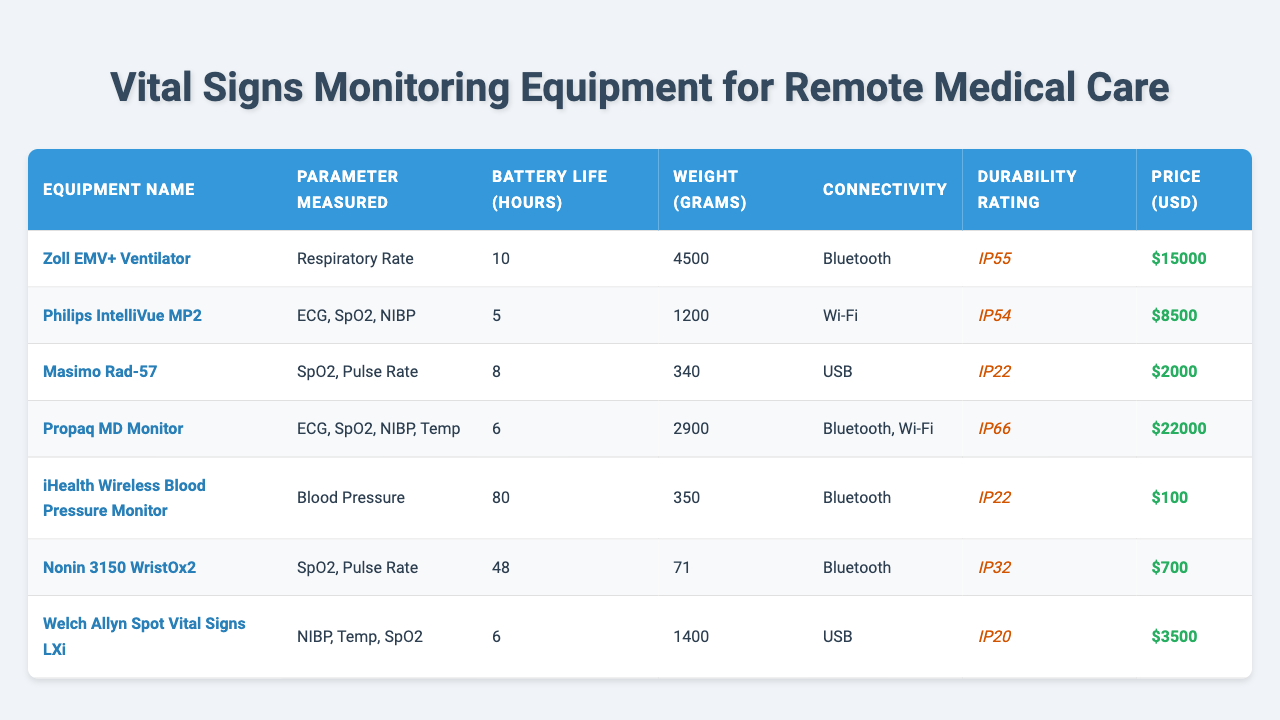What is the weight of the Zoll EMV+ Ventilator? The table lists the weight of the Zoll EMV+ Ventilator as 4500 grams.
Answer: 4500 grams How many parameters can the Propaq MD Monitor measure? The Propaq MD Monitor can measure ECG, SpO2, NIBP, and Temp, totaling 4 parameters.
Answer: 4 parameters Which equipment has the longest battery life? The iHealth Wireless Blood Pressure Monitor has a battery life of 80 hours, which is the longest among the listed equipment.
Answer: 80 hours Is the Masimo Rad-57 device the lightest among the options? Comparing all weights, the Masimo Rad-57 weighs 340 grams, which is lighter than most other devices, making it the lightest.
Answer: Yes What is the total price of the Zoll EMV+ Ventilator and Philips IntelliVue MP2? The prices are $15000 and $8500, respectively. Adding them gives $15000 + $8500 = $23500.
Answer: $23500 How many devices have a durability rating of IP66? The table shows that only the Propaq MD Monitor has a durability rating of IP66.
Answer: 1 device Which device measures Blood Pressure, and what is its price? The iHealth Wireless Blood Pressure Monitor measures Blood Pressure and is priced at $100.
Answer: $100 What is the average battery life of all devices listed? The battery lives are 10, 5, 8, 6, 80, 48, and 6 hours. Summing them (10 + 5 + 8 + 6 + 80 + 48 + 6) equals 163 hours. Dividing by 7 devices gives an average of 23.29 hours.
Answer: 23.29 hours Are all devices using Bluetooth connectivity? No, not all devices use Bluetooth; the Philips IntelliVue MP2 and Welch Allyn Spot Vital Signs LXi use Wi-Fi and USB respectively.
Answer: No What is the weight difference between the heaviest and lightest devices? The heaviest device is Zoll EMV+ Ventilator at 4500 grams, and the lightest is Nonin 3150 WristOx2 at 71 grams. The difference is 4500 - 71 = 4429 grams.
Answer: 4429 grams Which device offers multiple connectivity options? The Propaq MD Monitor offers two connectivity options: Bluetooth and Wi-Fi.
Answer: Propaq MD Monitor 